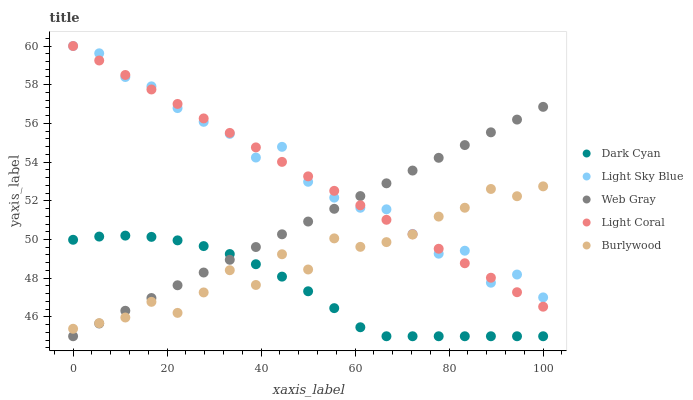Does Dark Cyan have the minimum area under the curve?
Answer yes or no. Yes. Does Light Sky Blue have the maximum area under the curve?
Answer yes or no. Yes. Does Light Coral have the minimum area under the curve?
Answer yes or no. No. Does Light Coral have the maximum area under the curve?
Answer yes or no. No. Is Light Coral the smoothest?
Answer yes or no. Yes. Is Burlywood the roughest?
Answer yes or no. Yes. Is Light Sky Blue the smoothest?
Answer yes or no. No. Is Light Sky Blue the roughest?
Answer yes or no. No. Does Dark Cyan have the lowest value?
Answer yes or no. Yes. Does Light Coral have the lowest value?
Answer yes or no. No. Does Light Sky Blue have the highest value?
Answer yes or no. Yes. Does Web Gray have the highest value?
Answer yes or no. No. Is Dark Cyan less than Light Coral?
Answer yes or no. Yes. Is Light Sky Blue greater than Dark Cyan?
Answer yes or no. Yes. Does Web Gray intersect Dark Cyan?
Answer yes or no. Yes. Is Web Gray less than Dark Cyan?
Answer yes or no. No. Is Web Gray greater than Dark Cyan?
Answer yes or no. No. Does Dark Cyan intersect Light Coral?
Answer yes or no. No. 